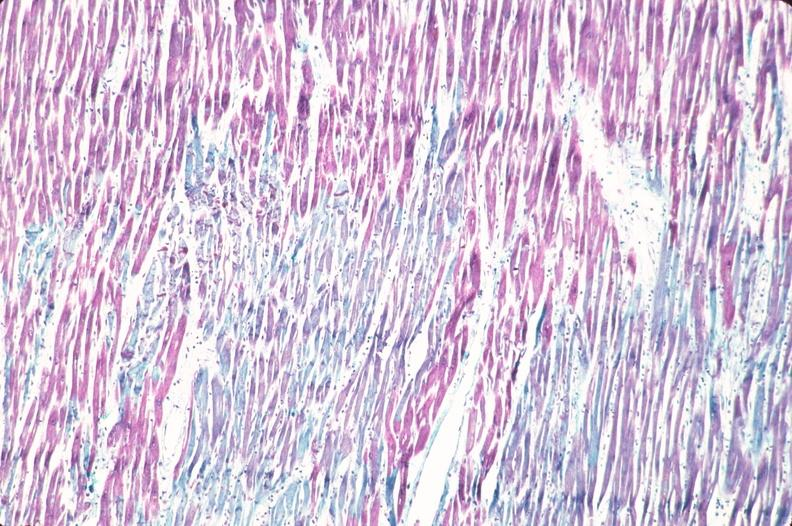does this image show heart, acute myocardial infarction?
Answer the question using a single word or phrase. Yes 